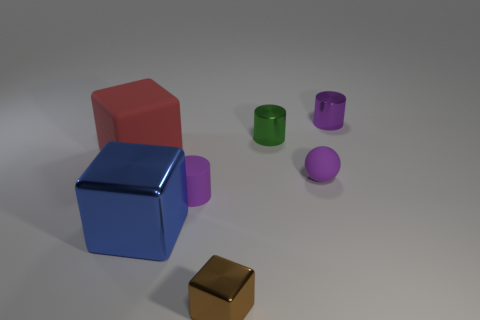Subtract all cyan blocks. Subtract all brown balls. How many blocks are left? 3 Add 1 tiny purple matte balls. How many objects exist? 8 Subtract all spheres. How many objects are left? 6 Add 4 big gray matte blocks. How many big gray matte blocks exist? 4 Subtract 2 purple cylinders. How many objects are left? 5 Subtract all small green metal cylinders. Subtract all tiny purple matte things. How many objects are left? 4 Add 1 balls. How many balls are left? 2 